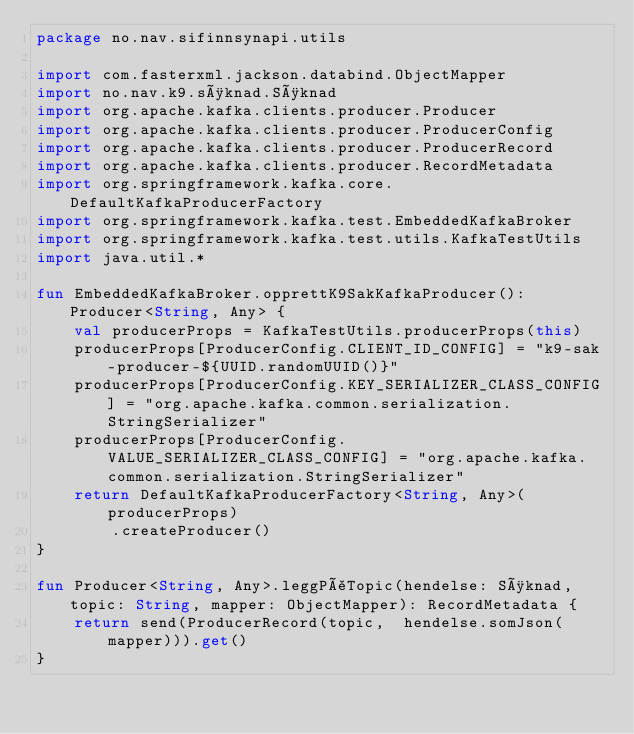<code> <loc_0><loc_0><loc_500><loc_500><_Kotlin_>package no.nav.sifinnsynapi.utils

import com.fasterxml.jackson.databind.ObjectMapper
import no.nav.k9.søknad.Søknad
import org.apache.kafka.clients.producer.Producer
import org.apache.kafka.clients.producer.ProducerConfig
import org.apache.kafka.clients.producer.ProducerRecord
import org.apache.kafka.clients.producer.RecordMetadata
import org.springframework.kafka.core.DefaultKafkaProducerFactory
import org.springframework.kafka.test.EmbeddedKafkaBroker
import org.springframework.kafka.test.utils.KafkaTestUtils
import java.util.*

fun EmbeddedKafkaBroker.opprettK9SakKafkaProducer(): Producer<String, Any> {
    val producerProps = KafkaTestUtils.producerProps(this)
    producerProps[ProducerConfig.CLIENT_ID_CONFIG] = "k9-sak-producer-${UUID.randomUUID()}"
    producerProps[ProducerConfig.KEY_SERIALIZER_CLASS_CONFIG] = "org.apache.kafka.common.serialization.StringSerializer"
    producerProps[ProducerConfig.VALUE_SERIALIZER_CLASS_CONFIG] = "org.apache.kafka.common.serialization.StringSerializer"
    return DefaultKafkaProducerFactory<String, Any>(producerProps)
        .createProducer()
}

fun Producer<String, Any>.leggPåTopic(hendelse: Søknad, topic: String, mapper: ObjectMapper): RecordMetadata {
    return send(ProducerRecord(topic,  hendelse.somJson(mapper))).get()
}
</code> 